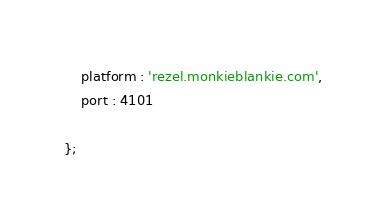<code> <loc_0><loc_0><loc_500><loc_500><_JavaScript_>    platform : 'rezel.monkieblankie.com',
    port : 4101

};
</code> 